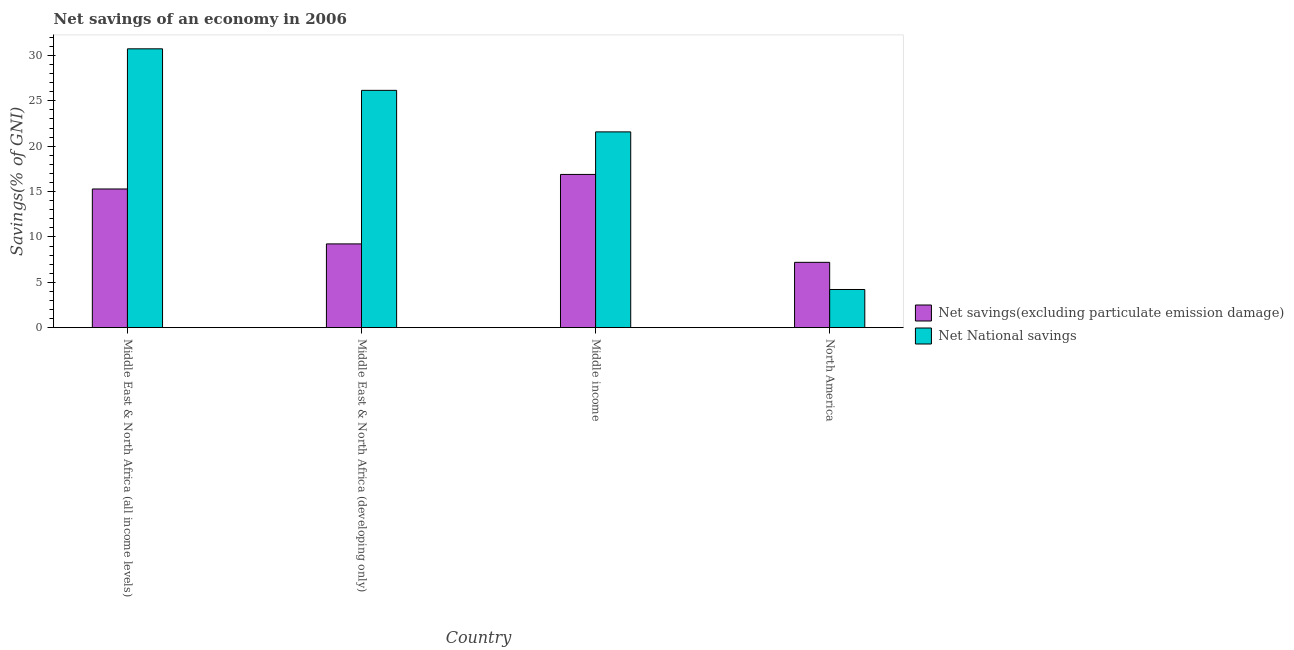How many different coloured bars are there?
Provide a succinct answer. 2. Are the number of bars per tick equal to the number of legend labels?
Give a very brief answer. Yes. Are the number of bars on each tick of the X-axis equal?
Give a very brief answer. Yes. How many bars are there on the 3rd tick from the left?
Offer a very short reply. 2. What is the label of the 4th group of bars from the left?
Keep it short and to the point. North America. What is the net national savings in North America?
Provide a short and direct response. 4.21. Across all countries, what is the maximum net savings(excluding particulate emission damage)?
Keep it short and to the point. 16.89. Across all countries, what is the minimum net savings(excluding particulate emission damage)?
Offer a very short reply. 7.2. In which country was the net savings(excluding particulate emission damage) maximum?
Give a very brief answer. Middle income. In which country was the net national savings minimum?
Your answer should be very brief. North America. What is the total net savings(excluding particulate emission damage) in the graph?
Provide a short and direct response. 48.61. What is the difference between the net savings(excluding particulate emission damage) in Middle East & North Africa (all income levels) and that in Middle East & North Africa (developing only)?
Keep it short and to the point. 6.05. What is the difference between the net national savings in Middle East & North Africa (all income levels) and the net savings(excluding particulate emission damage) in North America?
Provide a short and direct response. 23.53. What is the average net national savings per country?
Your response must be concise. 20.67. What is the difference between the net national savings and net savings(excluding particulate emission damage) in Middle East & North Africa (all income levels)?
Keep it short and to the point. 15.45. What is the ratio of the net national savings in Middle East & North Africa (all income levels) to that in Middle East & North Africa (developing only)?
Your answer should be compact. 1.18. What is the difference between the highest and the second highest net savings(excluding particulate emission damage)?
Keep it short and to the point. 1.6. What is the difference between the highest and the lowest net national savings?
Offer a terse response. 26.53. What does the 1st bar from the left in Middle East & North Africa (all income levels) represents?
Provide a succinct answer. Net savings(excluding particulate emission damage). What does the 1st bar from the right in North America represents?
Keep it short and to the point. Net National savings. How many bars are there?
Your response must be concise. 8. Are all the bars in the graph horizontal?
Provide a succinct answer. No. What is the difference between two consecutive major ticks on the Y-axis?
Provide a short and direct response. 5. Does the graph contain any zero values?
Your answer should be compact. No. Where does the legend appear in the graph?
Keep it short and to the point. Center right. What is the title of the graph?
Ensure brevity in your answer.  Net savings of an economy in 2006. What is the label or title of the Y-axis?
Make the answer very short. Savings(% of GNI). What is the Savings(% of GNI) of Net savings(excluding particulate emission damage) in Middle East & North Africa (all income levels)?
Your answer should be very brief. 15.29. What is the Savings(% of GNI) of Net National savings in Middle East & North Africa (all income levels)?
Your response must be concise. 30.73. What is the Savings(% of GNI) in Net savings(excluding particulate emission damage) in Middle East & North Africa (developing only)?
Provide a short and direct response. 9.23. What is the Savings(% of GNI) in Net National savings in Middle East & North Africa (developing only)?
Your answer should be compact. 26.16. What is the Savings(% of GNI) in Net savings(excluding particulate emission damage) in Middle income?
Offer a very short reply. 16.89. What is the Savings(% of GNI) in Net National savings in Middle income?
Ensure brevity in your answer.  21.58. What is the Savings(% of GNI) in Net savings(excluding particulate emission damage) in North America?
Ensure brevity in your answer.  7.2. What is the Savings(% of GNI) of Net National savings in North America?
Your answer should be very brief. 4.21. Across all countries, what is the maximum Savings(% of GNI) in Net savings(excluding particulate emission damage)?
Ensure brevity in your answer.  16.89. Across all countries, what is the maximum Savings(% of GNI) in Net National savings?
Your answer should be very brief. 30.73. Across all countries, what is the minimum Savings(% of GNI) of Net savings(excluding particulate emission damage)?
Ensure brevity in your answer.  7.2. Across all countries, what is the minimum Savings(% of GNI) in Net National savings?
Your response must be concise. 4.21. What is the total Savings(% of GNI) of Net savings(excluding particulate emission damage) in the graph?
Offer a very short reply. 48.61. What is the total Savings(% of GNI) of Net National savings in the graph?
Offer a terse response. 82.68. What is the difference between the Savings(% of GNI) in Net savings(excluding particulate emission damage) in Middle East & North Africa (all income levels) and that in Middle East & North Africa (developing only)?
Ensure brevity in your answer.  6.05. What is the difference between the Savings(% of GNI) in Net National savings in Middle East & North Africa (all income levels) and that in Middle East & North Africa (developing only)?
Offer a very short reply. 4.58. What is the difference between the Savings(% of GNI) in Net savings(excluding particulate emission damage) in Middle East & North Africa (all income levels) and that in Middle income?
Keep it short and to the point. -1.6. What is the difference between the Savings(% of GNI) of Net National savings in Middle East & North Africa (all income levels) and that in Middle income?
Offer a terse response. 9.16. What is the difference between the Savings(% of GNI) in Net savings(excluding particulate emission damage) in Middle East & North Africa (all income levels) and that in North America?
Offer a terse response. 8.09. What is the difference between the Savings(% of GNI) of Net National savings in Middle East & North Africa (all income levels) and that in North America?
Your answer should be compact. 26.53. What is the difference between the Savings(% of GNI) in Net savings(excluding particulate emission damage) in Middle East & North Africa (developing only) and that in Middle income?
Offer a terse response. -7.66. What is the difference between the Savings(% of GNI) of Net National savings in Middle East & North Africa (developing only) and that in Middle income?
Make the answer very short. 4.58. What is the difference between the Savings(% of GNI) in Net savings(excluding particulate emission damage) in Middle East & North Africa (developing only) and that in North America?
Your answer should be very brief. 2.03. What is the difference between the Savings(% of GNI) in Net National savings in Middle East & North Africa (developing only) and that in North America?
Keep it short and to the point. 21.95. What is the difference between the Savings(% of GNI) of Net savings(excluding particulate emission damage) in Middle income and that in North America?
Provide a short and direct response. 9.69. What is the difference between the Savings(% of GNI) in Net National savings in Middle income and that in North America?
Ensure brevity in your answer.  17.37. What is the difference between the Savings(% of GNI) of Net savings(excluding particulate emission damage) in Middle East & North Africa (all income levels) and the Savings(% of GNI) of Net National savings in Middle East & North Africa (developing only)?
Your response must be concise. -10.87. What is the difference between the Savings(% of GNI) in Net savings(excluding particulate emission damage) in Middle East & North Africa (all income levels) and the Savings(% of GNI) in Net National savings in Middle income?
Give a very brief answer. -6.29. What is the difference between the Savings(% of GNI) in Net savings(excluding particulate emission damage) in Middle East & North Africa (all income levels) and the Savings(% of GNI) in Net National savings in North America?
Ensure brevity in your answer.  11.08. What is the difference between the Savings(% of GNI) in Net savings(excluding particulate emission damage) in Middle East & North Africa (developing only) and the Savings(% of GNI) in Net National savings in Middle income?
Make the answer very short. -12.35. What is the difference between the Savings(% of GNI) in Net savings(excluding particulate emission damage) in Middle East & North Africa (developing only) and the Savings(% of GNI) in Net National savings in North America?
Offer a terse response. 5.03. What is the difference between the Savings(% of GNI) of Net savings(excluding particulate emission damage) in Middle income and the Savings(% of GNI) of Net National savings in North America?
Your response must be concise. 12.68. What is the average Savings(% of GNI) of Net savings(excluding particulate emission damage) per country?
Your response must be concise. 12.15. What is the average Savings(% of GNI) of Net National savings per country?
Your answer should be very brief. 20.67. What is the difference between the Savings(% of GNI) of Net savings(excluding particulate emission damage) and Savings(% of GNI) of Net National savings in Middle East & North Africa (all income levels)?
Your answer should be very brief. -15.45. What is the difference between the Savings(% of GNI) of Net savings(excluding particulate emission damage) and Savings(% of GNI) of Net National savings in Middle East & North Africa (developing only)?
Give a very brief answer. -16.93. What is the difference between the Savings(% of GNI) in Net savings(excluding particulate emission damage) and Savings(% of GNI) in Net National savings in Middle income?
Offer a very short reply. -4.69. What is the difference between the Savings(% of GNI) in Net savings(excluding particulate emission damage) and Savings(% of GNI) in Net National savings in North America?
Your answer should be compact. 2.99. What is the ratio of the Savings(% of GNI) in Net savings(excluding particulate emission damage) in Middle East & North Africa (all income levels) to that in Middle East & North Africa (developing only)?
Offer a terse response. 1.66. What is the ratio of the Savings(% of GNI) of Net National savings in Middle East & North Africa (all income levels) to that in Middle East & North Africa (developing only)?
Your response must be concise. 1.18. What is the ratio of the Savings(% of GNI) of Net savings(excluding particulate emission damage) in Middle East & North Africa (all income levels) to that in Middle income?
Your response must be concise. 0.91. What is the ratio of the Savings(% of GNI) of Net National savings in Middle East & North Africa (all income levels) to that in Middle income?
Your answer should be compact. 1.42. What is the ratio of the Savings(% of GNI) of Net savings(excluding particulate emission damage) in Middle East & North Africa (all income levels) to that in North America?
Offer a very short reply. 2.12. What is the ratio of the Savings(% of GNI) of Net National savings in Middle East & North Africa (all income levels) to that in North America?
Your answer should be compact. 7.31. What is the ratio of the Savings(% of GNI) in Net savings(excluding particulate emission damage) in Middle East & North Africa (developing only) to that in Middle income?
Keep it short and to the point. 0.55. What is the ratio of the Savings(% of GNI) in Net National savings in Middle East & North Africa (developing only) to that in Middle income?
Your answer should be very brief. 1.21. What is the ratio of the Savings(% of GNI) in Net savings(excluding particulate emission damage) in Middle East & North Africa (developing only) to that in North America?
Give a very brief answer. 1.28. What is the ratio of the Savings(% of GNI) in Net National savings in Middle East & North Africa (developing only) to that in North America?
Provide a succinct answer. 6.22. What is the ratio of the Savings(% of GNI) of Net savings(excluding particulate emission damage) in Middle income to that in North America?
Your response must be concise. 2.35. What is the ratio of the Savings(% of GNI) in Net National savings in Middle income to that in North America?
Your answer should be compact. 5.13. What is the difference between the highest and the second highest Savings(% of GNI) in Net savings(excluding particulate emission damage)?
Keep it short and to the point. 1.6. What is the difference between the highest and the second highest Savings(% of GNI) of Net National savings?
Your answer should be compact. 4.58. What is the difference between the highest and the lowest Savings(% of GNI) in Net savings(excluding particulate emission damage)?
Provide a short and direct response. 9.69. What is the difference between the highest and the lowest Savings(% of GNI) of Net National savings?
Keep it short and to the point. 26.53. 